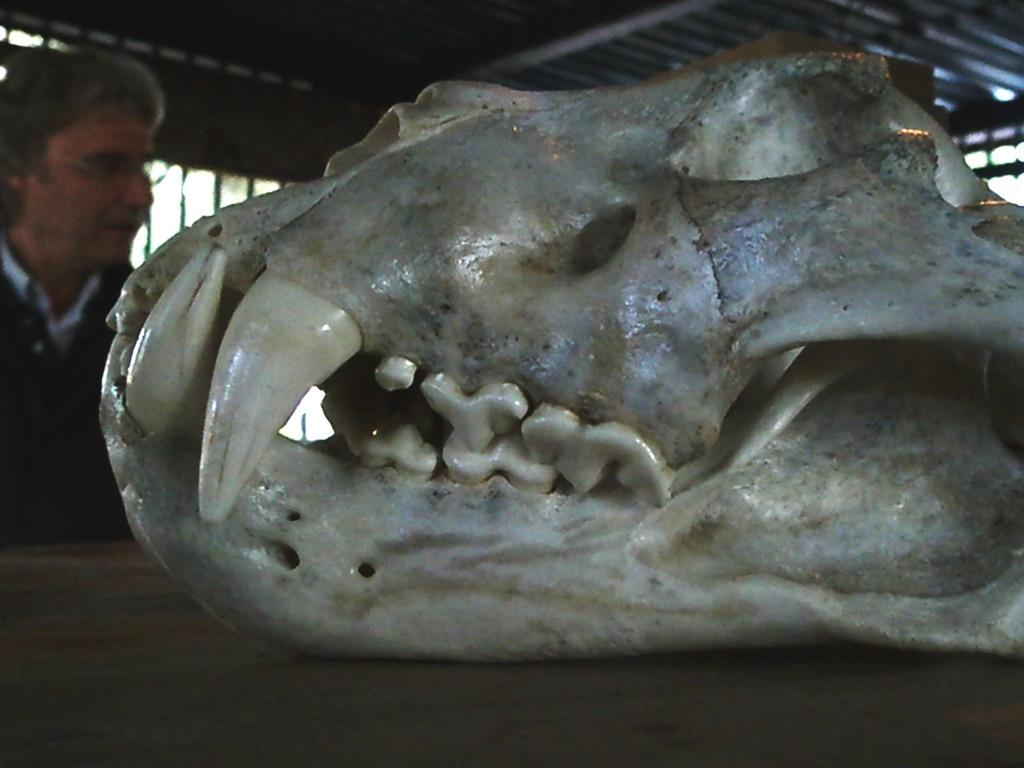What is the main subject in the front of the image? There is a skeleton of an object in the front of the image. What can be seen in the background of the image? There is a man and a grill in the background of the image. What is the color of the grill? The grill is black in color. What is the rate of the ear in the image? There is no ear present in the image. 